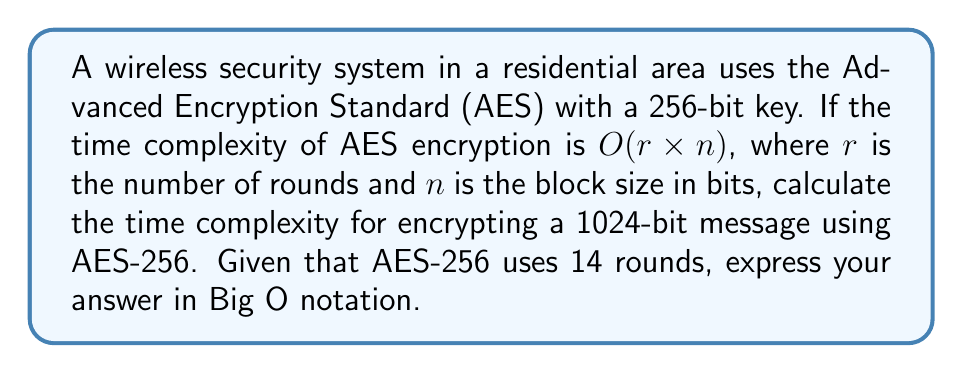Provide a solution to this math problem. Let's approach this step-by-step:

1) The time complexity of AES is given as $O(r \times n)$, where:
   $r$ = number of rounds
   $n$ = block size in bits

2) For AES-256:
   $r = 14$ rounds
   The standard block size for AES is 128 bits, so $n = 128$

3) Substituting these values into the complexity formula:
   $O(14 \times 128) = O(1792)$

4) However, this is for encrypting a single 128-bit block. Our message is 1024 bits.

5) To encrypt a 1024-bit message, we need to determine how many 128-bit blocks it consists of:
   $1024 \div 128 = 8$ blocks

6) Therefore, we need to perform the encryption 8 times.

7) In Big O notation, constant factors are ignored. Multiplying by 8 doesn't change the order of complexity.

Thus, the time complexity remains $O(1792)$, which simplifies to $O(1)$ in Big O notation, as it's a constant time regardless of input size.
Answer: $O(1)$ 